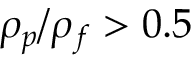Convert formula to latex. <formula><loc_0><loc_0><loc_500><loc_500>\rho _ { p } / \rho _ { f } > 0 . 5</formula> 